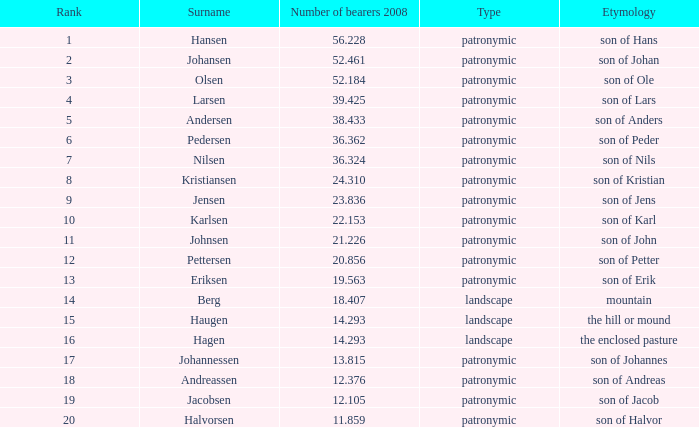When considering the year 2008, the surname hansen, and a rank under 1, what is the highest number of bearers? None. 